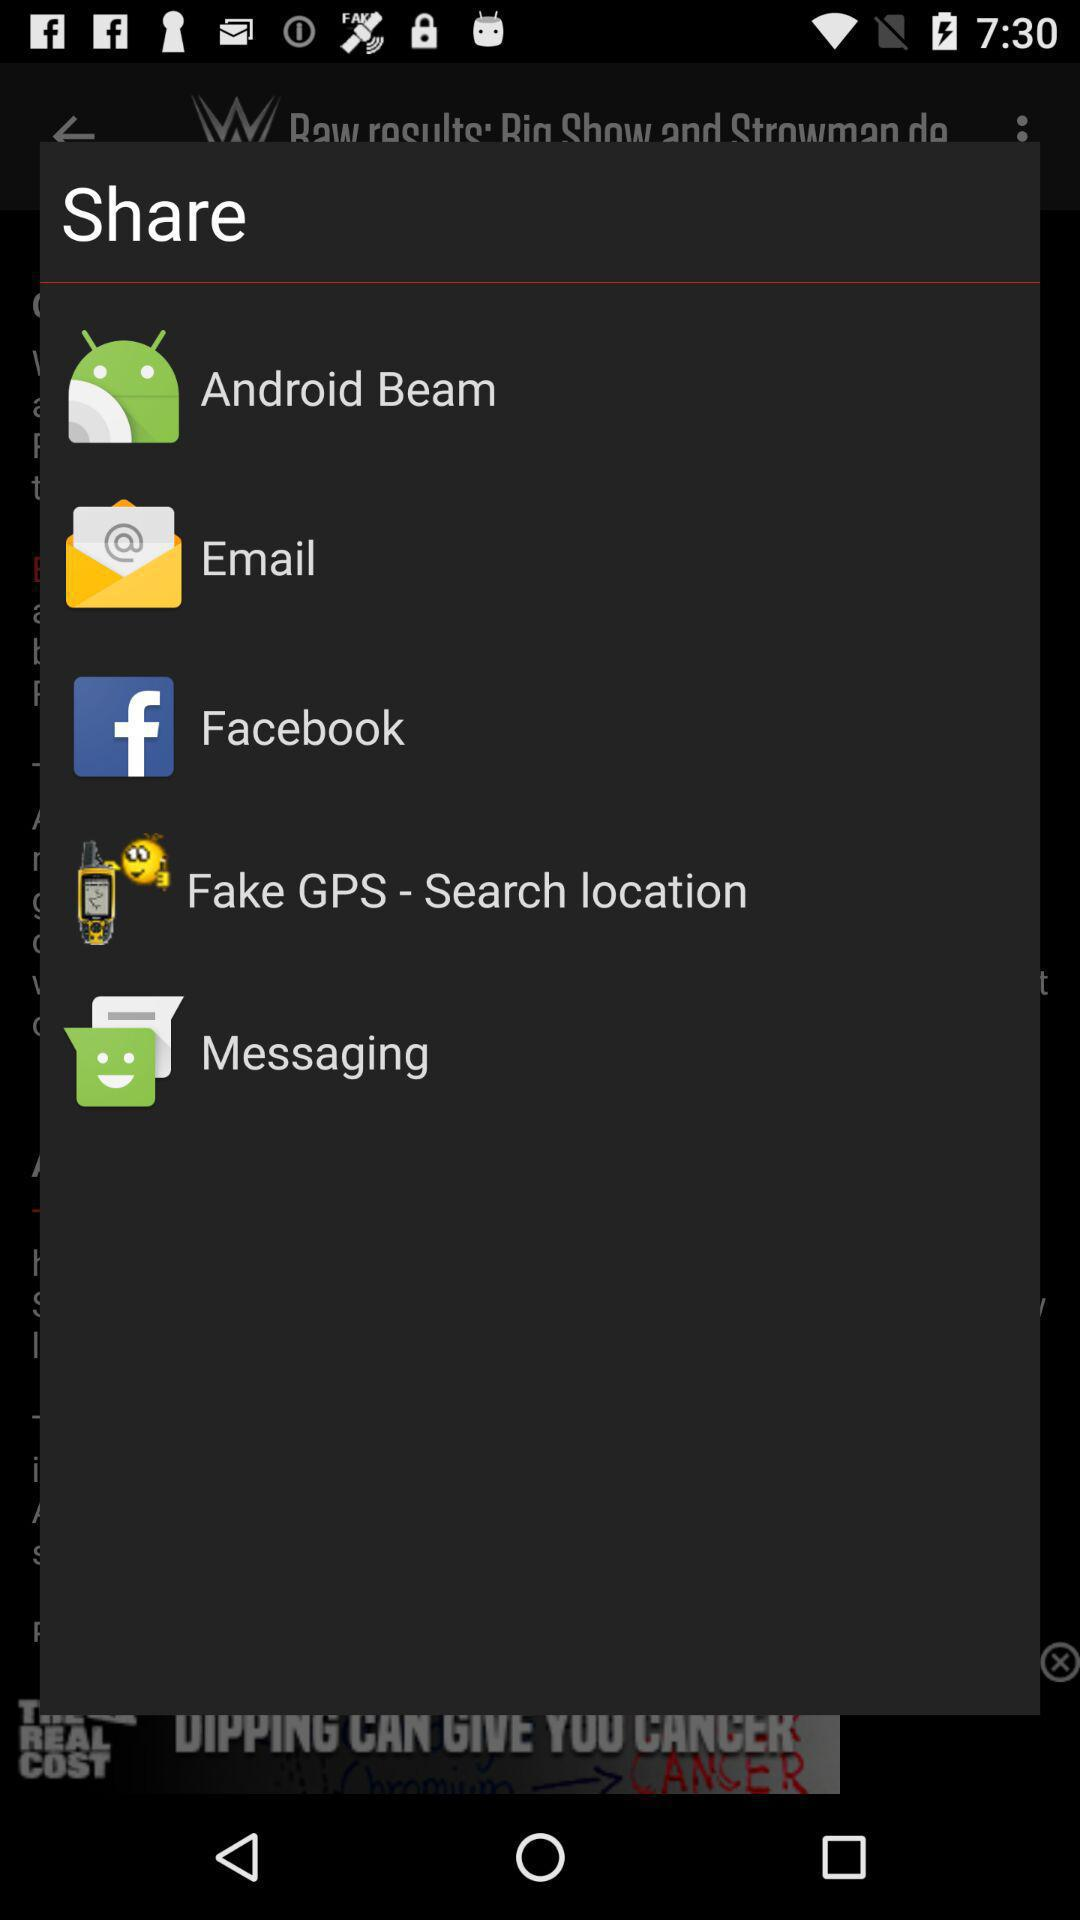Which application can be used to share the content? The applications that can be used to share the content are "Android Beam", "Email", "Facebook", "Fake GPS - Search location" and "Messaging". 